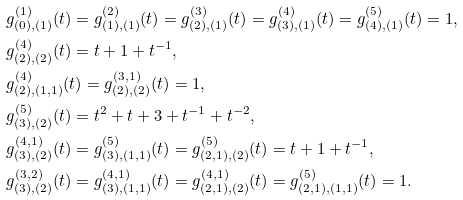Convert formula to latex. <formula><loc_0><loc_0><loc_500><loc_500>& g _ { ( 0 ) , ( 1 ) } ^ { ( 1 ) } ( t ) = g _ { ( 1 ) , ( 1 ) } ^ { ( 2 ) } ( t ) = g _ { ( 2 ) , ( 1 ) } ^ { ( 3 ) } ( t ) = g _ { ( 3 ) , ( 1 ) } ^ { ( 4 ) } ( t ) = g _ { ( 4 ) , ( 1 ) } ^ { ( 5 ) } ( t ) = 1 , \\ & g _ { ( 2 ) , ( 2 ) } ^ { ( 4 ) } ( t ) = t + 1 + t ^ { - 1 } , \\ & g _ { ( 2 ) , ( 1 , 1 ) } ^ { ( 4 ) } ( t ) = g _ { ( 2 ) , ( 2 ) } ^ { ( 3 , 1 ) } ( t ) = 1 , \\ & g _ { ( 3 ) , ( 2 ) } ^ { ( 5 ) } ( t ) = t ^ { 2 } + t + 3 + t ^ { - 1 } + t ^ { - 2 } , \\ & g _ { ( 3 ) , ( 2 ) } ^ { ( 4 , 1 ) } ( t ) = g _ { ( 3 ) , ( 1 , 1 ) } ^ { ( 5 ) } ( t ) = g _ { ( 2 , 1 ) , ( 2 ) } ^ { ( 5 ) } ( t ) = t + 1 + t ^ { - 1 } , \\ & g _ { ( 3 ) , ( 2 ) } ^ { ( 3 , 2 ) } ( t ) = g _ { ( 3 ) , ( 1 , 1 ) } ^ { ( 4 , 1 ) } ( t ) = g _ { ( 2 , 1 ) , ( 2 ) } ^ { ( 4 , 1 ) } ( t ) = g _ { ( 2 , 1 ) , ( 1 , 1 ) } ^ { ( 5 ) } ( t ) = 1 .</formula> 